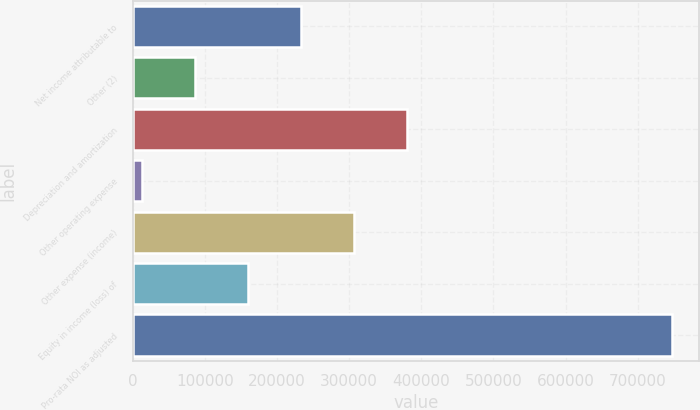<chart> <loc_0><loc_0><loc_500><loc_500><bar_chart><fcel>Net income attributable to<fcel>Other (2)<fcel>Depreciation and amortization<fcel>Other operating expense<fcel>Other expense (income)<fcel>Equity in income (loss) of<fcel>Pro-rata NOI as adjusted<nl><fcel>233148<fcel>85966.8<fcel>380330<fcel>12376<fcel>306739<fcel>159558<fcel>748284<nl></chart> 